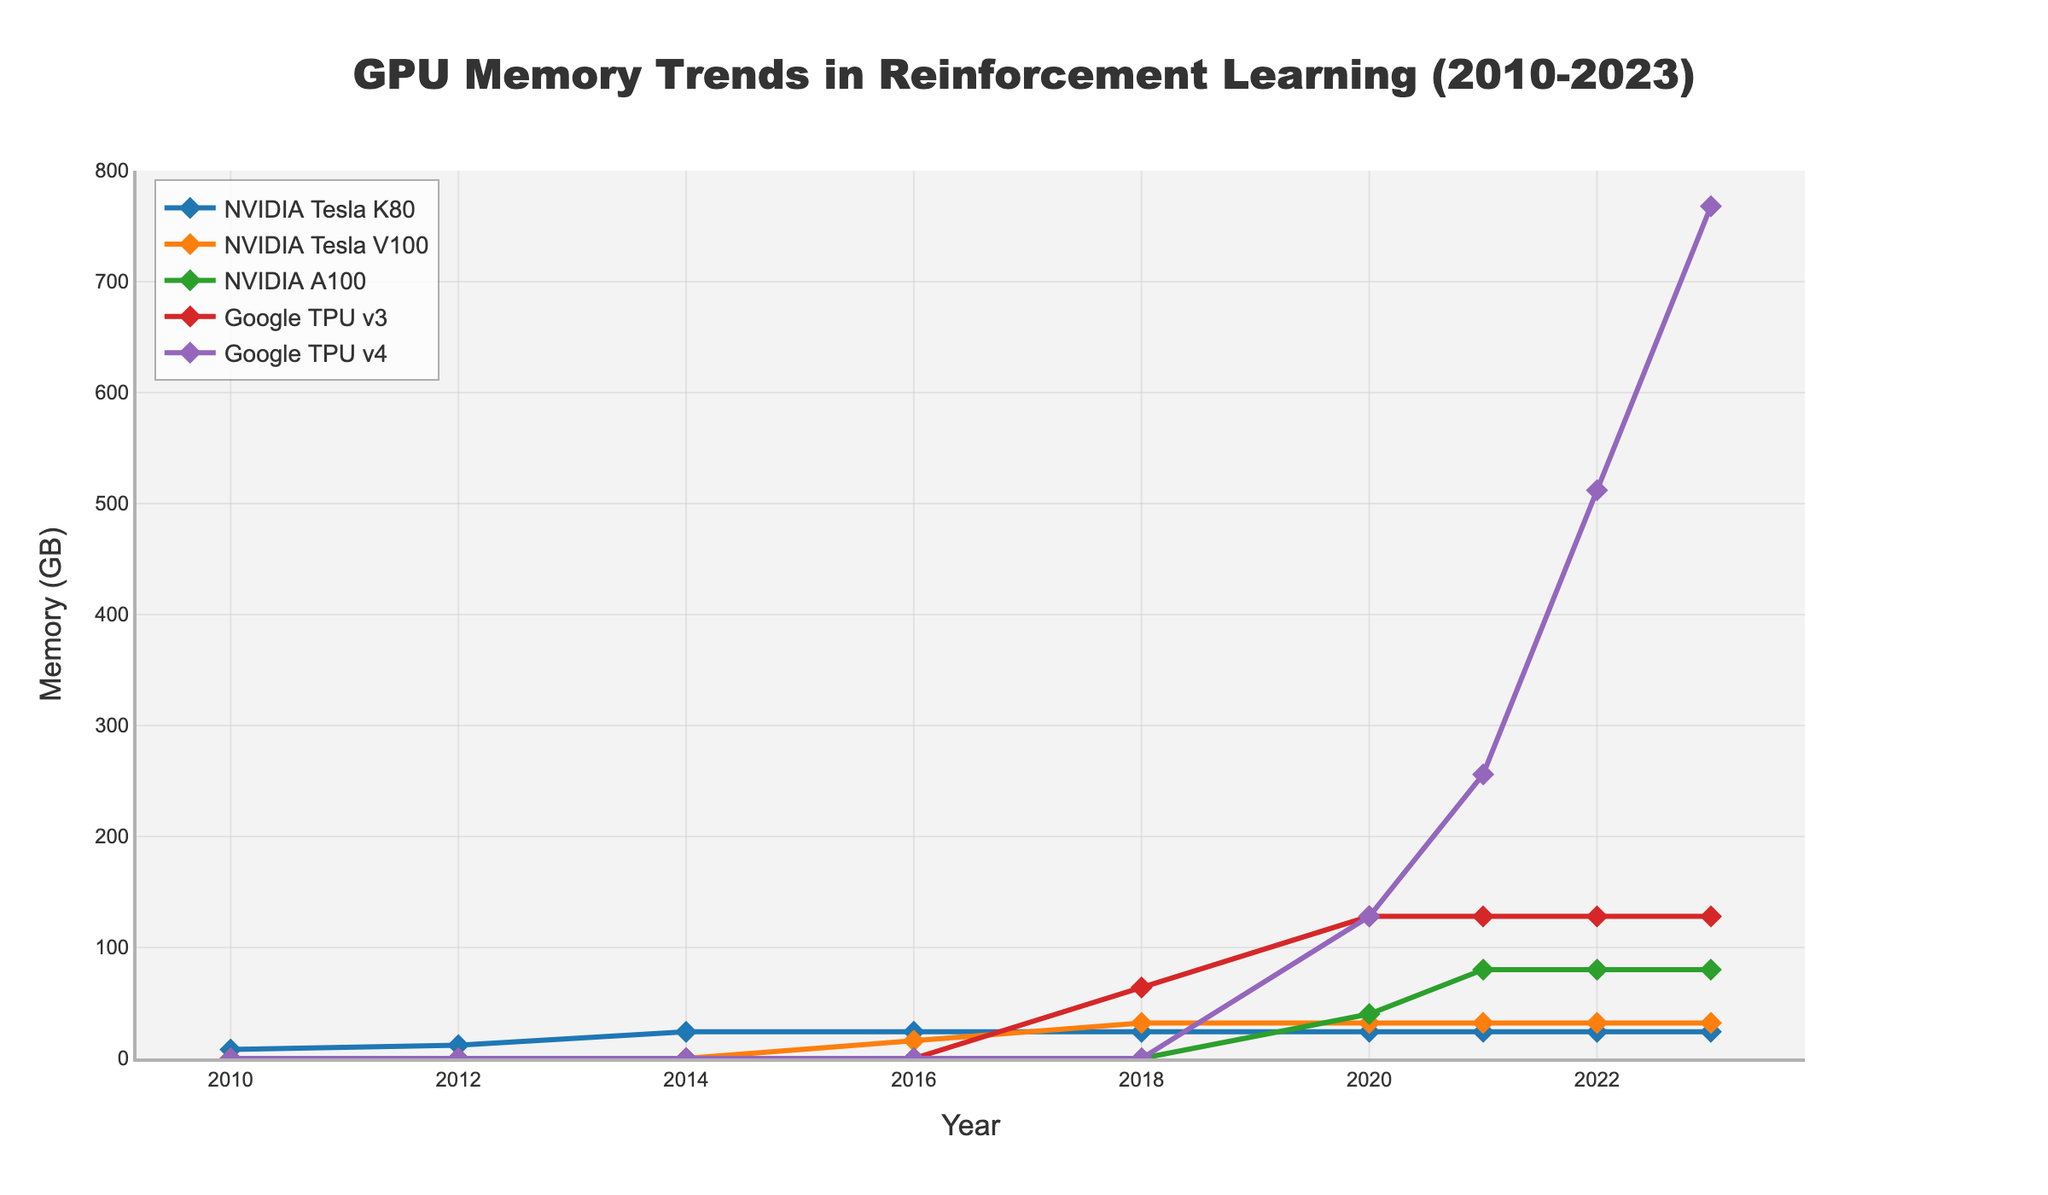What is the maximum memory usage recorded for Google TPU v4 by 2023? From the plotted data, you can clearly see that the memory usage for Google TPU v4 in 2023 is the highest point on the chart for that series. By looking at the y-axis value corresponding to this point, the maximum memory usage for Google TPU v4 by 2023 is 768 GB.
Answer: 768 GB How does the memory usage of NVIDIA Tesla K80 compare between 2010 and 2014? To answer this question, locate the points for NVIDIA Tesla K80 in 2010 and 2014 on the graph. In 2010, the memory usage is 8 GB, and in 2014, it is 24 GB. Compare these values to see that the memory usage tripled from 8 GB to 24 GB.
Answer: It tripled What is the average memory usage of NVIDIA Tesla V100 from 2016 to 2023? First, identify the memory usage of NVIDIA Tesla V100 for the years 2016, 2018, 2020, 2021, 2022, and 2023 from the chart. The values are 16 GB, 32 GB, 32 GB, 32 GB, 32 GB, and 32 GB respectively. Sum these values and divide by the number of years (6): (16 + 32 + 32 + 32 + 32 + 32) / 6 = 176 / 6 ≈ 29.33 GB.
Answer: 29.33 GB What trend do you observe in the memory usage of Google TPU v3 from its introduction to 2023? Google TPU v3 was introduced in 2018 with 64 GB of memory. Observing the trend on the graph from 2018 to 2023, we can see that the memory usage remains constant at 128 GB starting from 2020. This shows an increasing trend between 2018 and 2020, and it stabilizes from 2020 onwards.
Answer: Increased initially, then stabilized Which GPU had the highest memory increase over any single year, and what was the value of this increase? Examine each GPU's memory usage year-over-year. Google TPU v4 shows the most significant increase between 2022 and 2023, from 512 GB to 768 GB. The increase is calculated as 768 GB - 512 GB = 256 GB.
Answer: Google TPU v4, 256 GB Comparing NVIDIA A100 and Google TPU v4, which one had a higher memory usage in 2021? To answer this, identify the plotted points of NVIDIA A100 and Google TPU v4 for the year 2021. NVIDIA A100 has 80 GB, and Google TPU v4 has 256 GB in 2021. Therefore, Google TPU v4 had a higher memory usage.
Answer: Google TPU v4 By how much did the memory usage of NVIDIA Tesla K80 remain constant after 2014? Observing the chart, find the value of NVIDIA Tesla K80 for every year after 2014 up to 2023. The value stays at 24 GB consistently from 2014 to 2023. Therefore the increase in memory usage after 2014 was 0 GB.
Answer: 0 GB What year did Google TPU v4 reach 512 GB of memory usage, and how long did it take to reach there from its introduction? Locate the year when Google TPU v4 reaches 512 GB, which is 2022. Google TPU v4 was introduced in 2020. Therefore, it took from 2020 to 2022, which is 2 years, to reach 512 GB.
Answer: 2022, 2 years 